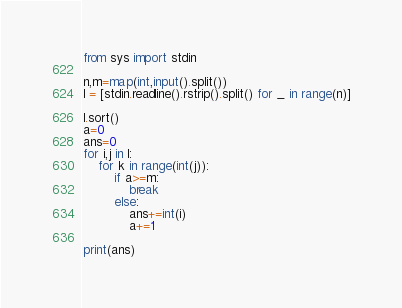Convert code to text. <code><loc_0><loc_0><loc_500><loc_500><_Python_>from sys import stdin

n,m=map(int,input().split())
l = [stdin.readline().rstrip().split() for _ in range(n)]

l.sort()
a=0
ans=0
for i,j in l:
    for k in range(int(j)):
        if a>=m:
            break
        else:
            ans+=int(i)
            a+=1

print(ans)</code> 